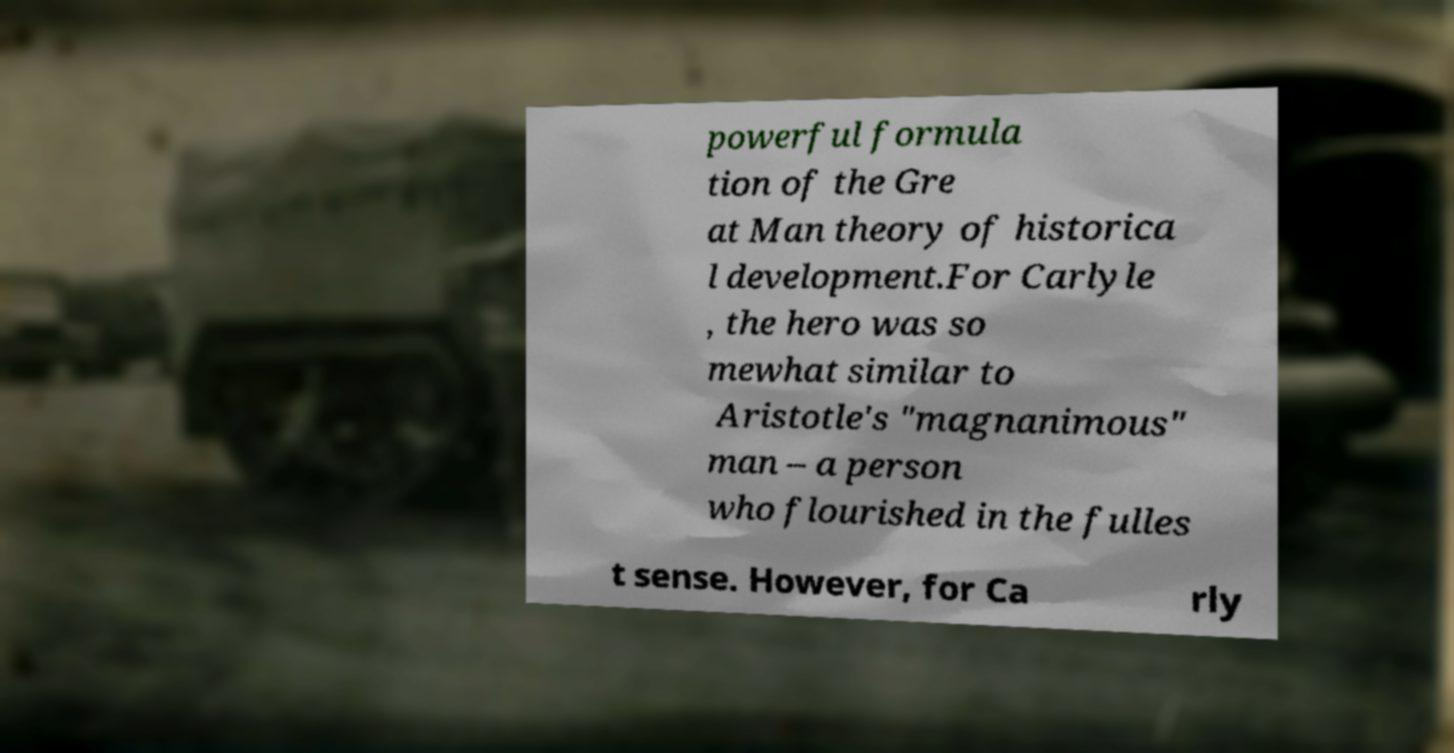Could you extract and type out the text from this image? powerful formula tion of the Gre at Man theory of historica l development.For Carlyle , the hero was so mewhat similar to Aristotle's "magnanimous" man – a person who flourished in the fulles t sense. However, for Ca rly 